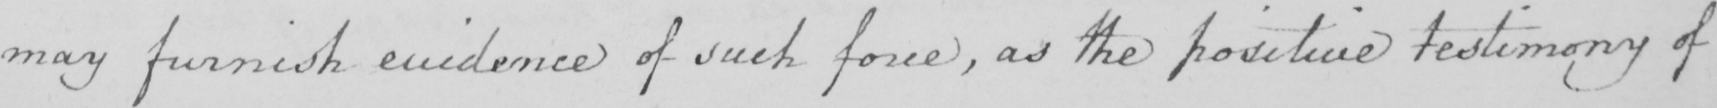What text is written in this handwritten line? may furnish evidence of such force , as the positive testimony of 